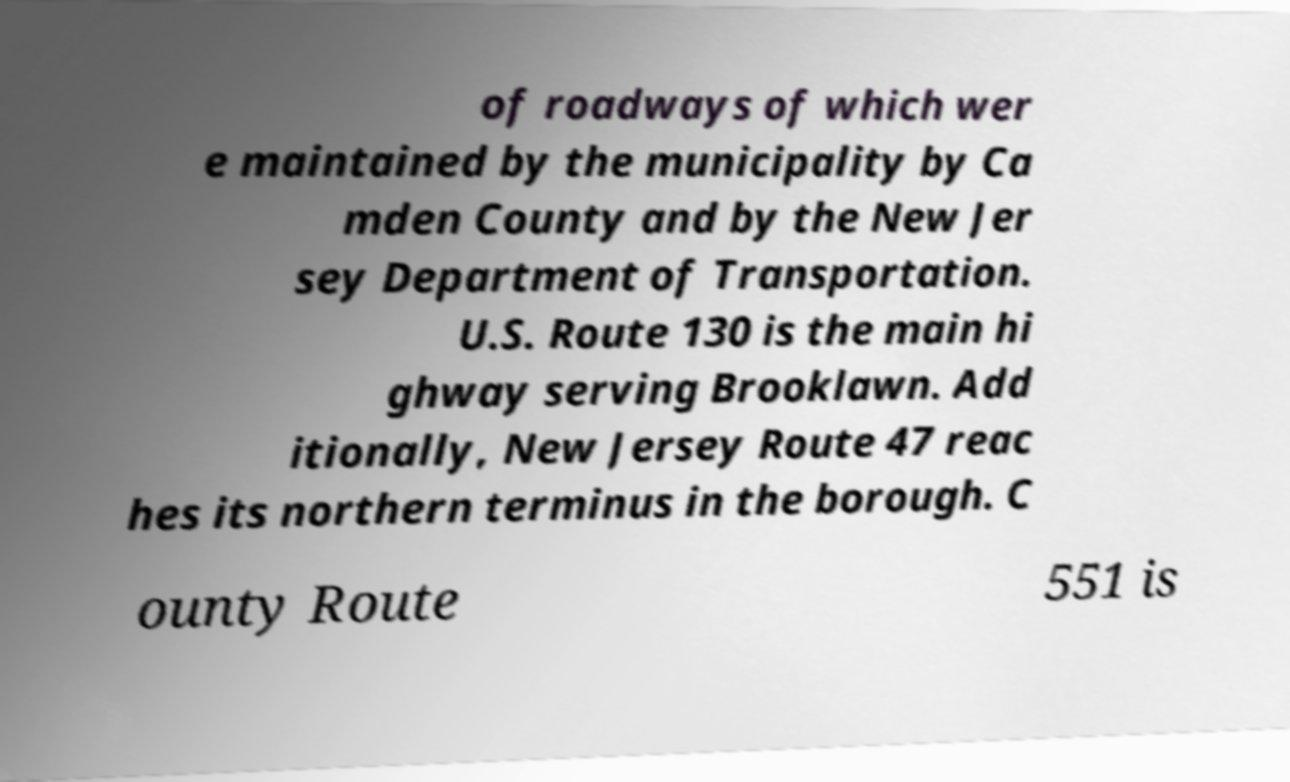What messages or text are displayed in this image? I need them in a readable, typed format. of roadways of which wer e maintained by the municipality by Ca mden County and by the New Jer sey Department of Transportation. U.S. Route 130 is the main hi ghway serving Brooklawn. Add itionally, New Jersey Route 47 reac hes its northern terminus in the borough. C ounty Route 551 is 